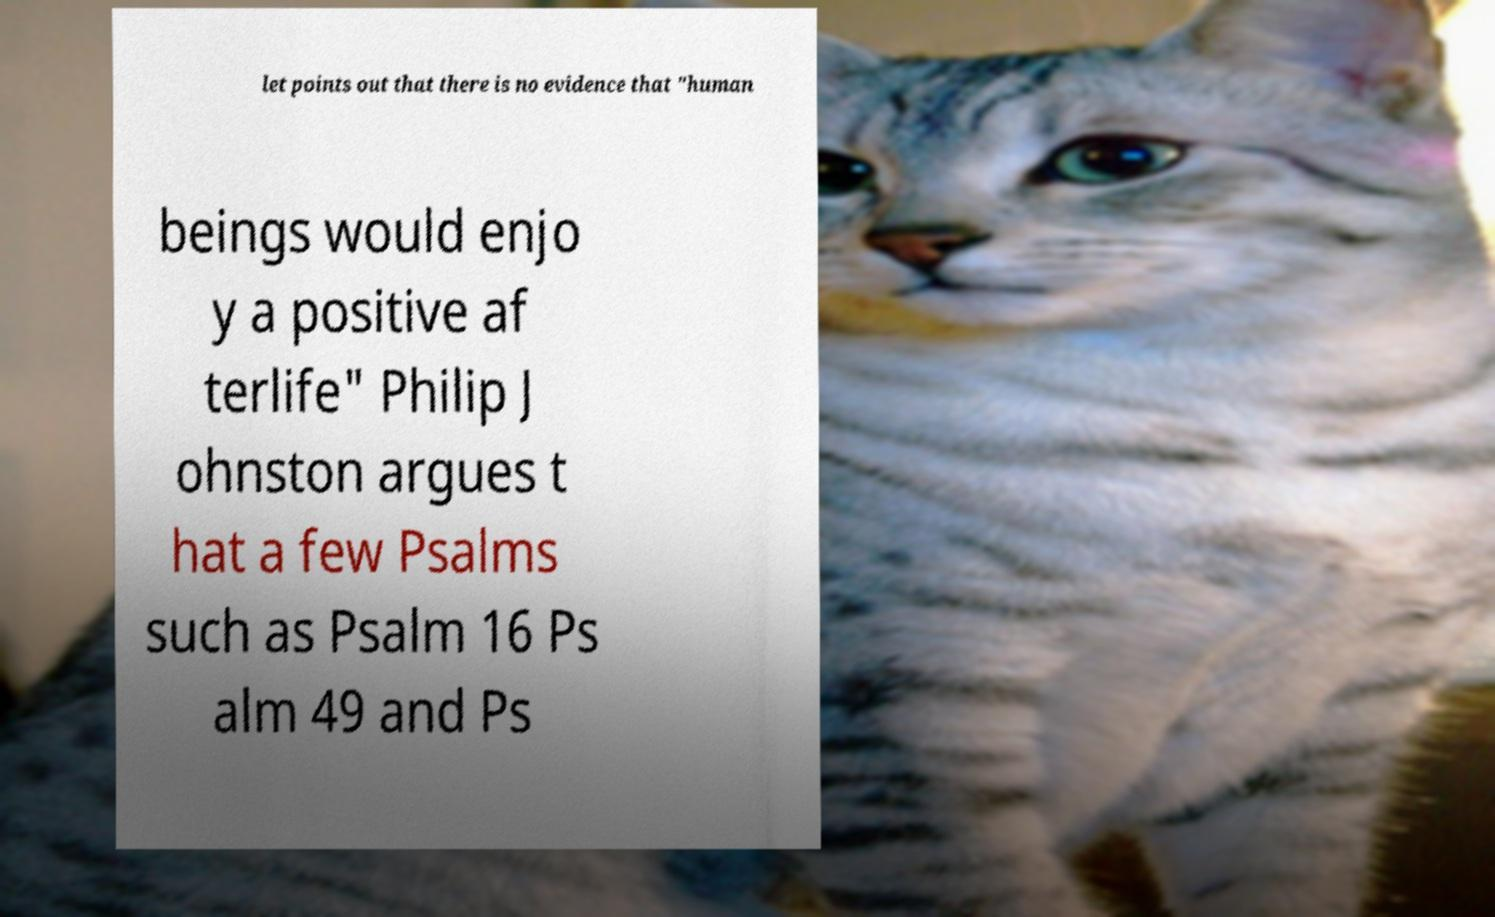Please read and relay the text visible in this image. What does it say? let points out that there is no evidence that "human beings would enjo y a positive af terlife" Philip J ohnston argues t hat a few Psalms such as Psalm 16 Ps alm 49 and Ps 